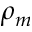Convert formula to latex. <formula><loc_0><loc_0><loc_500><loc_500>\rho _ { m }</formula> 